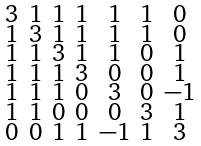Convert formula to latex. <formula><loc_0><loc_0><loc_500><loc_500>\begin{smallmatrix} 3 & 1 & 1 & 1 & 1 & 1 & 0 \\ 1 & 3 & 1 & 1 & 1 & 1 & 0 \\ 1 & 1 & 3 & 1 & 1 & 0 & 1 \\ 1 & 1 & 1 & 3 & 0 & 0 & 1 \\ 1 & 1 & 1 & 0 & 3 & 0 & - 1 \\ 1 & 1 & 0 & 0 & 0 & 3 & 1 \\ 0 & 0 & 1 & 1 & - 1 & 1 & 3 \end{smallmatrix}</formula> 